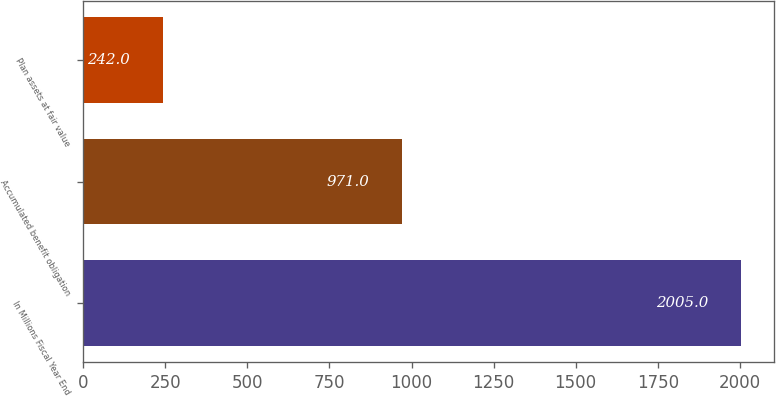Convert chart. <chart><loc_0><loc_0><loc_500><loc_500><bar_chart><fcel>In Millions Fiscal Year End<fcel>Accumulated benefit obligation<fcel>Plan assets at fair value<nl><fcel>2005<fcel>971<fcel>242<nl></chart> 